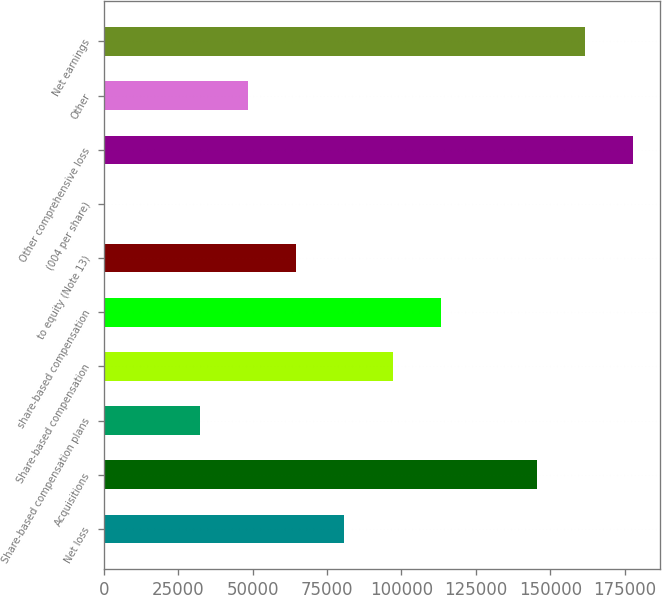Convert chart to OTSL. <chart><loc_0><loc_0><loc_500><loc_500><bar_chart><fcel>Net loss<fcel>Acquisitions<fcel>Share-based compensation plans<fcel>Share-based compensation<fcel>share-based compensation<fcel>to equity (Note 13)<fcel>(004 per share)<fcel>Other comprehensive loss<fcel>Other<fcel>Net earnings<nl><fcel>80857.2<fcel>145543<fcel>32343.1<fcel>97028.6<fcel>113200<fcel>64685.8<fcel>0.39<fcel>177885<fcel>48514.5<fcel>161714<nl></chart> 